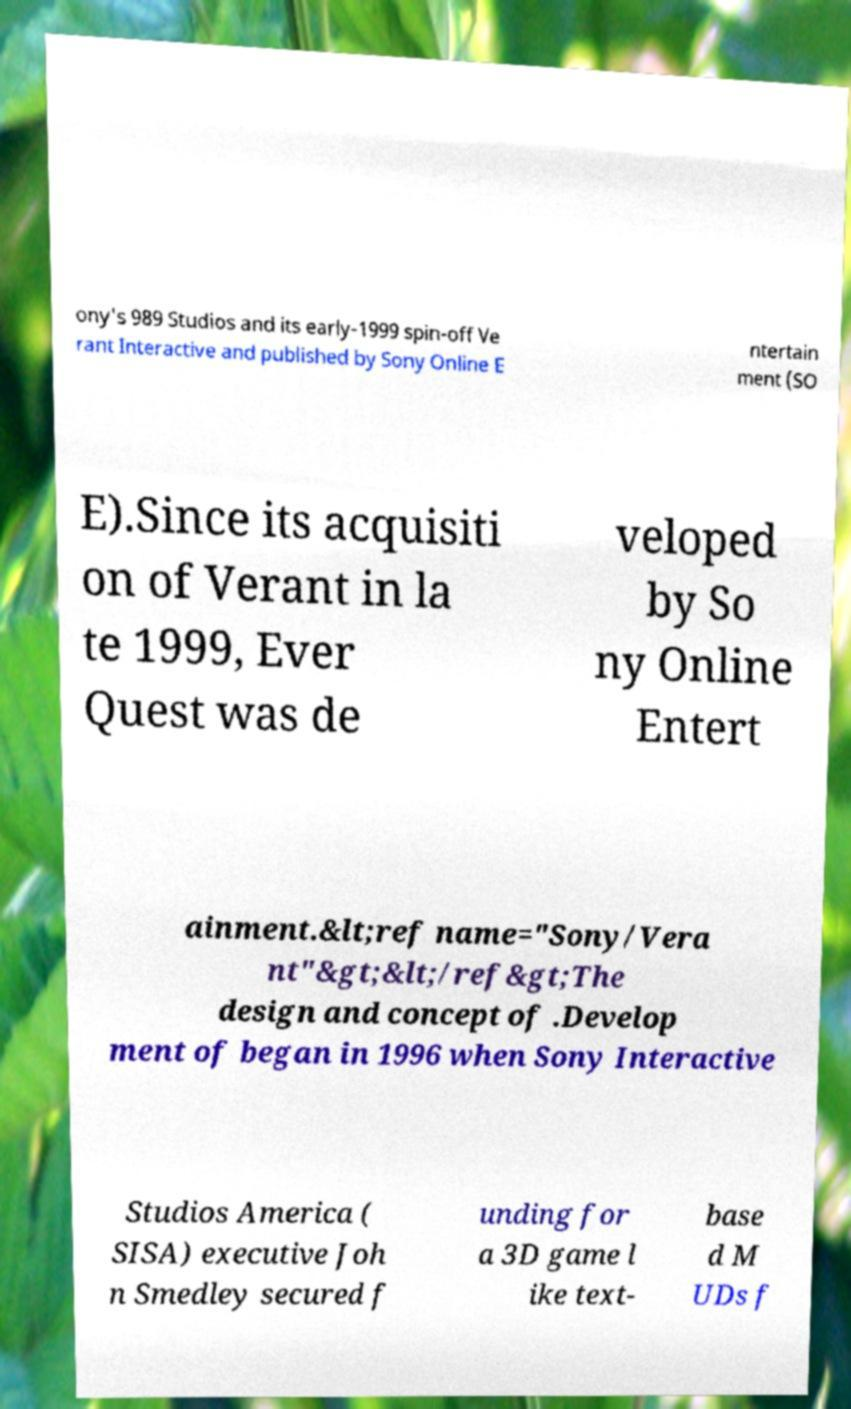Can you accurately transcribe the text from the provided image for me? ony's 989 Studios and its early-1999 spin-off Ve rant Interactive and published by Sony Online E ntertain ment (SO E).Since its acquisiti on of Verant in la te 1999, Ever Quest was de veloped by So ny Online Entert ainment.&lt;ref name="Sony/Vera nt"&gt;&lt;/ref&gt;The design and concept of .Develop ment of began in 1996 when Sony Interactive Studios America ( SISA) executive Joh n Smedley secured f unding for a 3D game l ike text- base d M UDs f 